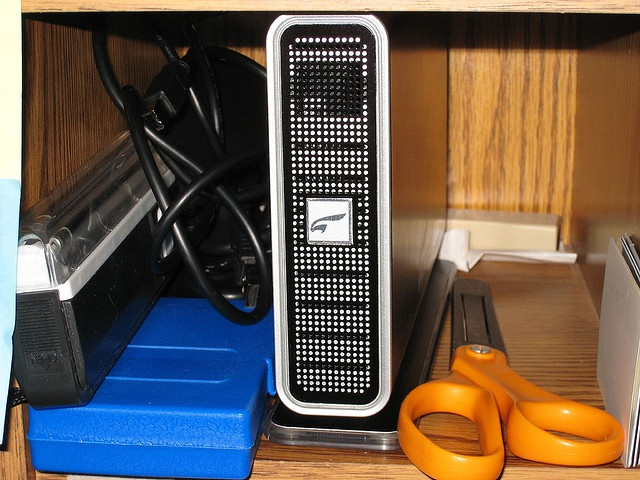Describe the objects in this image and their specific colors. I can see scissors in lightyellow, red, orange, and maroon tones in this image. 